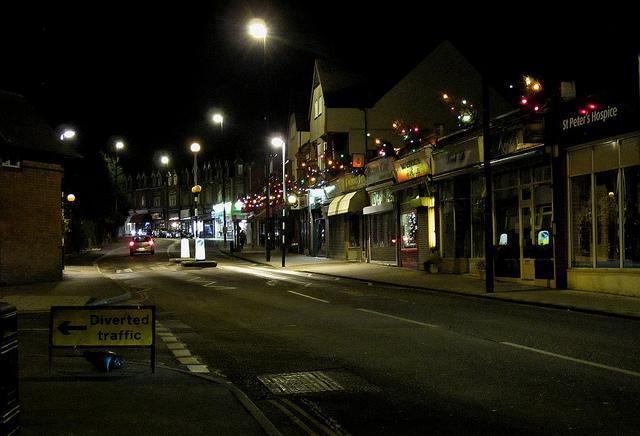How many columns of hot dogs are lined up on the grill?
Give a very brief answer. 0. 